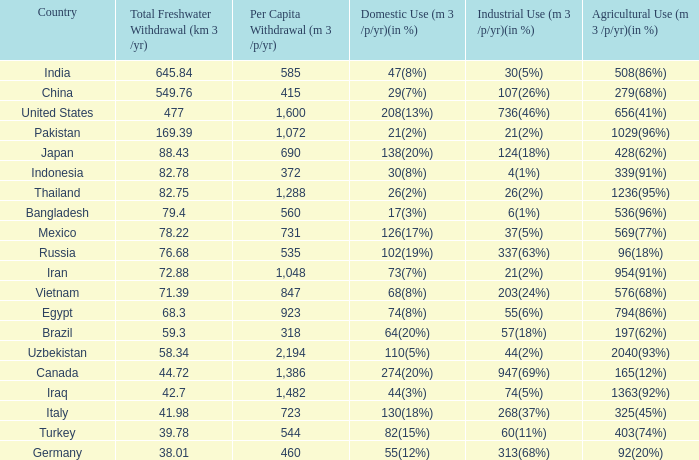Determine the typical total freshwater withdrawal (km 3 / None. 